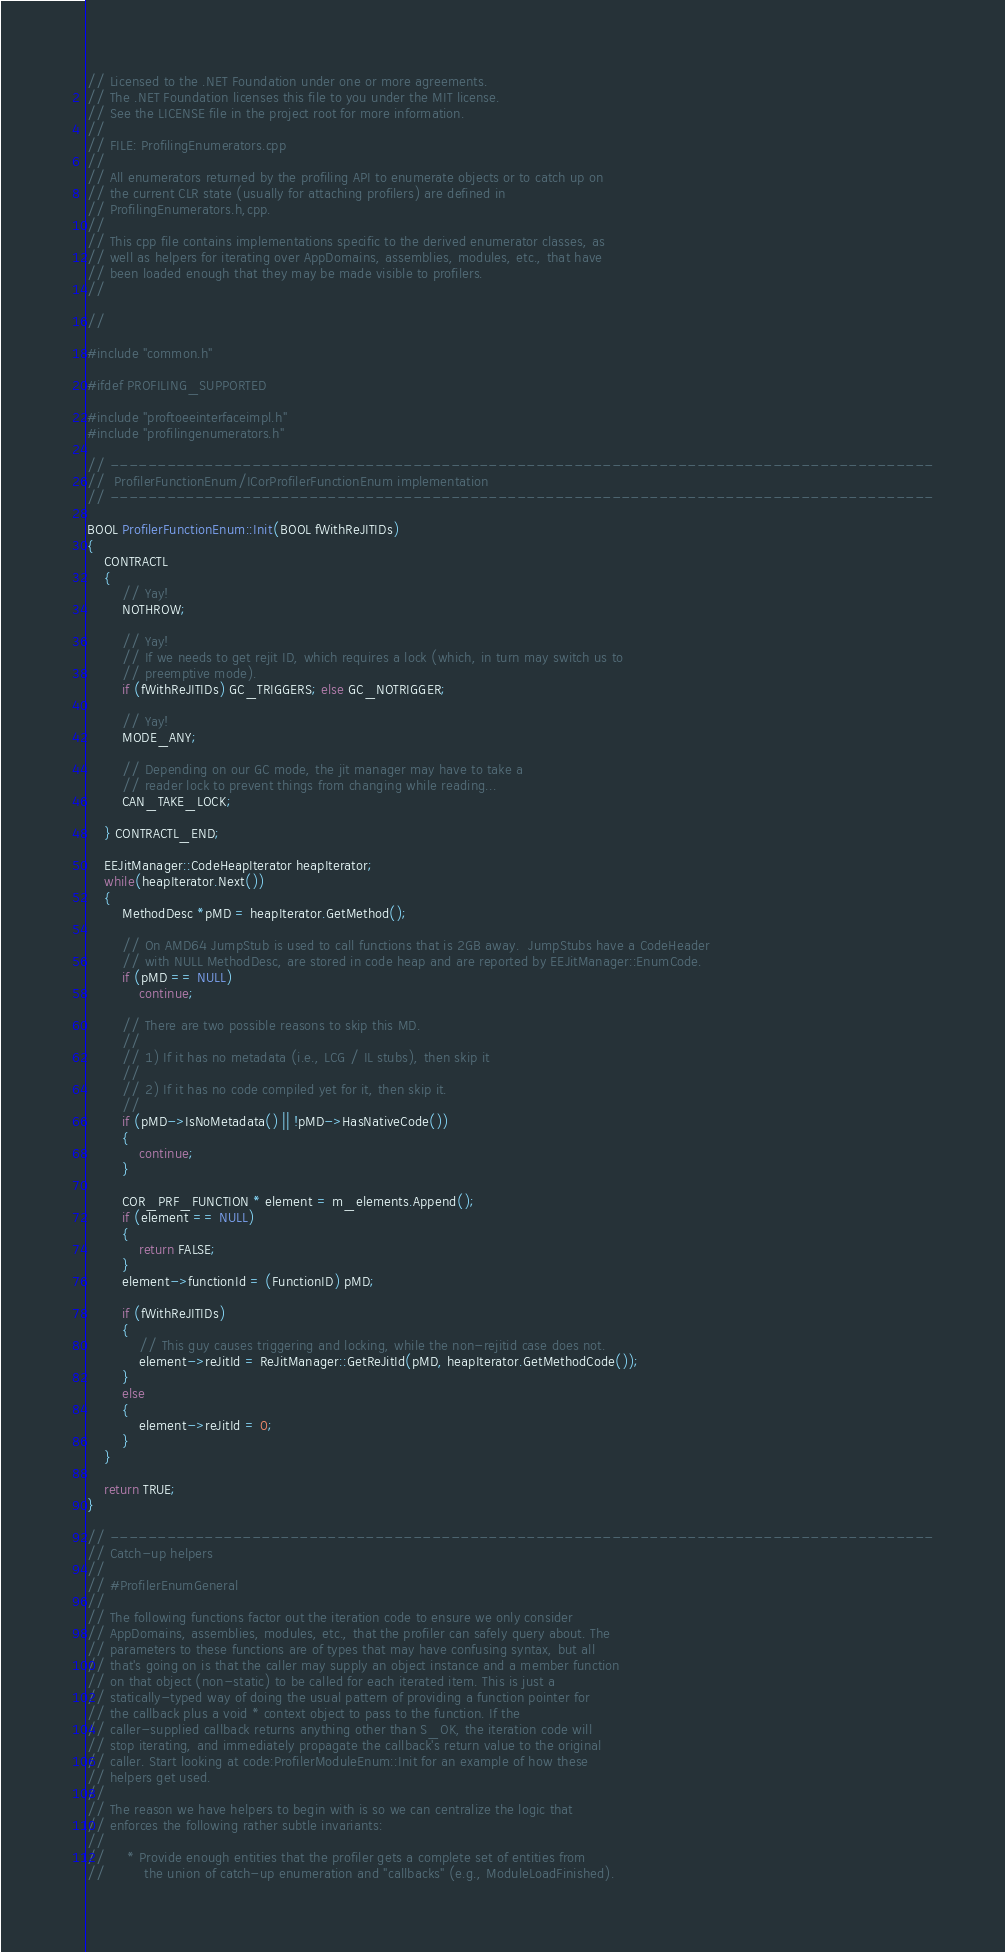Convert code to text. <code><loc_0><loc_0><loc_500><loc_500><_C++_>// Licensed to the .NET Foundation under one or more agreements.
// The .NET Foundation licenses this file to you under the MIT license.
// See the LICENSE file in the project root for more information.
//
// FILE: ProfilingEnumerators.cpp
//
// All enumerators returned by the profiling API to enumerate objects or to catch up on
// the current CLR state (usually for attaching profilers) are defined in
// ProfilingEnumerators.h,cpp.
// 
// This cpp file contains implementations specific to the derived enumerator classes, as
// well as helpers for iterating over AppDomains, assemblies, modules, etc., that have
// been loaded enough that they may be made visible to profilers.
//

// 

#include "common.h"

#ifdef PROFILING_SUPPORTED

#include "proftoeeinterfaceimpl.h"
#include "profilingenumerators.h"

// ---------------------------------------------------------------------------------------
//  ProfilerFunctionEnum/ICorProfilerFunctionEnum implementation
// ---------------------------------------------------------------------------------------

BOOL ProfilerFunctionEnum::Init(BOOL fWithReJITIDs)
{
    CONTRACTL 
    {
        // Yay!
        NOTHROW;

        // Yay!
        // If we needs to get rejit ID, which requires a lock (which, in turn may switch us to
        // preemptive mode).
        if (fWithReJITIDs) GC_TRIGGERS; else GC_NOTRIGGER;

        // Yay!
        MODE_ANY;

        // Depending on our GC mode, the jit manager may have to take a
        // reader lock to prevent things from changing while reading...
        CAN_TAKE_LOCK;

    } CONTRACTL_END;

    EEJitManager::CodeHeapIterator heapIterator;
    while(heapIterator.Next())
    {
        MethodDesc *pMD = heapIterator.GetMethod();

        // On AMD64 JumpStub is used to call functions that is 2GB away.  JumpStubs have a CodeHeader 
        // with NULL MethodDesc, are stored in code heap and are reported by EEJitManager::EnumCode.
        if (pMD == NULL)
            continue;

        // There are two possible reasons to skip this MD.
        //
        // 1) If it has no metadata (i.e., LCG / IL stubs), then skip it
        //
        // 2) If it has no code compiled yet for it, then skip it. 
        //
        if (pMD->IsNoMetadata() || !pMD->HasNativeCode())
        {
            continue;
        }

        COR_PRF_FUNCTION * element = m_elements.Append();
        if (element == NULL)
        {
            return FALSE;
        }
        element->functionId = (FunctionID) pMD;

        if (fWithReJITIDs)
        {
            // This guy causes triggering and locking, while the non-rejitid case does not.
            element->reJitId = ReJitManager::GetReJitId(pMD, heapIterator.GetMethodCode());
        }
        else
        {
            element->reJitId = 0;
        }
    }

    return TRUE;
}

// ---------------------------------------------------------------------------------------
// Catch-up helpers
// 
// #ProfilerEnumGeneral
// 
// The following functions factor out the iteration code to ensure we only consider
// AppDomains, assemblies, modules, etc., that the profiler can safely query about. The
// parameters to these functions are of types that may have confusing syntax, but all
// that's going on is that the caller may supply an object instance and a member function
// on that object (non-static) to be called for each iterated item. This is just a
// statically-typed way of doing the usual pattern of providing a function pointer for
// the callback plus a void * context object to pass to the function. If the
// caller-supplied callback returns anything other than S_OK, the iteration code will
// stop iterating, and immediately propagate the callback's return value to the original
// caller. Start looking at code:ProfilerModuleEnum::Init for an example of how these
// helpers get used.
// 
// The reason we have helpers to begin with is so we can centralize the logic that
// enforces the following rather subtle invariants:
// 
//     * Provide enough entities that the profiler gets a complete set of entities from
//         the union of catch-up enumeration and "callbacks" (e.g., ModuleLoadFinished).</code> 